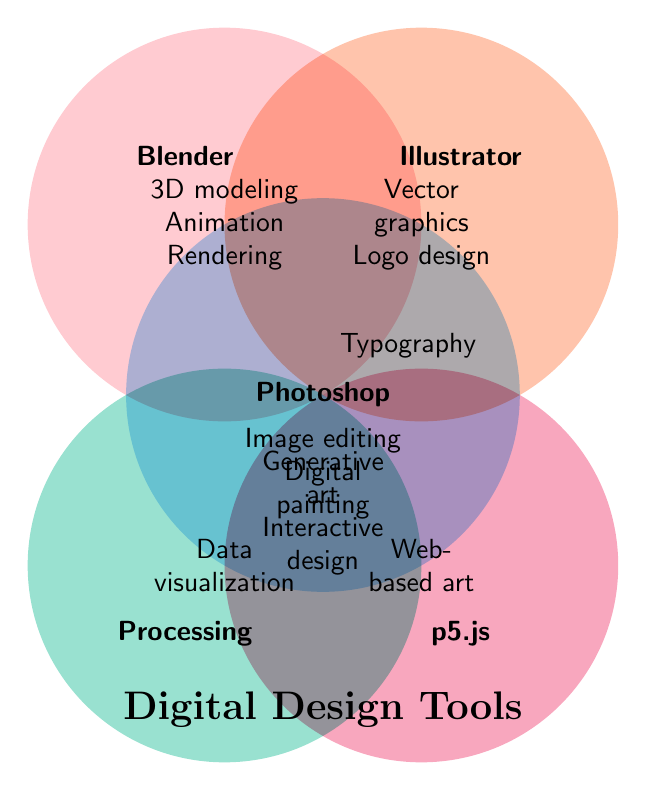How many tools share the feature 'Generative art'? Look for the circles that include 'Generative art'. It appears in Processing and p5.js.
Answer: 2 Which tool is associated with '3D modeling'? Identify the tool that is mentioned alongside '3D modeling'. It is Blender.
Answer: Blender What feature is shared by Photoshop and Illustrator? Find the overlapping area between the Photoshop and Illustrator circles. The feature is Typography.
Answer: Typography Which tools have 'Interactive design' as a feature? Look for the circles that include 'Interactive design'. It appears in Processing and p5.js.
Answer: 2 List all features of Blender. Identify all the text inside the Blender circle. They include 3D modeling, Animation, and Rendering.
Answer: 3D modeling, Animation, Rendering Which tool does not share any features with others? Find the tool that does not have any overlapping areas with other circles. It is Blender.
Answer: Blender How many tools are associated with 'Typography'? Count the number of tools sharing the feature 'Typography'. These tools are Photoshop and Illustrator.
Answer: 2 Which two tools have the most shared features listed? Check for the overlap areas with labels indicating multiple features. The tools are Processing and p5.js, with Generative art and Interactive design.
Answer: Processing and p5.js How many unique features does Illustrator have? Exclude shared features from the Illustrator circle. Unique features are Vector graphics and Logo design.
Answer: 2 What feature is located at the intersection of Processing and p5.js? Identify the overlapping area between these circles. The feature is 'Generative art' and 'Interactive design'.
Answer: Generative art, Interactive design 